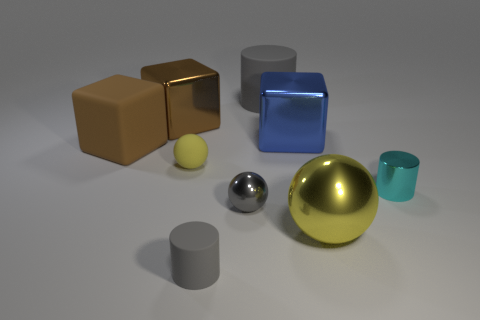The yellow metal thing has what shape?
Give a very brief answer. Sphere. Is there another block of the same color as the matte cube?
Your response must be concise. Yes. Are there more metallic blocks to the left of the matte ball than small red metallic blocks?
Your response must be concise. Yes. There is a cyan shiny object; is its shape the same as the rubber object that is in front of the small matte sphere?
Give a very brief answer. Yes. Are any big red metal cylinders visible?
Give a very brief answer. No. What number of big objects are either yellow objects or brown objects?
Keep it short and to the point. 3. Are there more gray objects in front of the small yellow rubber thing than yellow shiny objects that are to the left of the metal cylinder?
Offer a terse response. Yes. Do the big sphere and the thing that is right of the large yellow ball have the same material?
Keep it short and to the point. Yes. The shiny cylinder is what color?
Give a very brief answer. Cyan. What shape is the big metal object in front of the gray sphere?
Your answer should be compact. Sphere. 